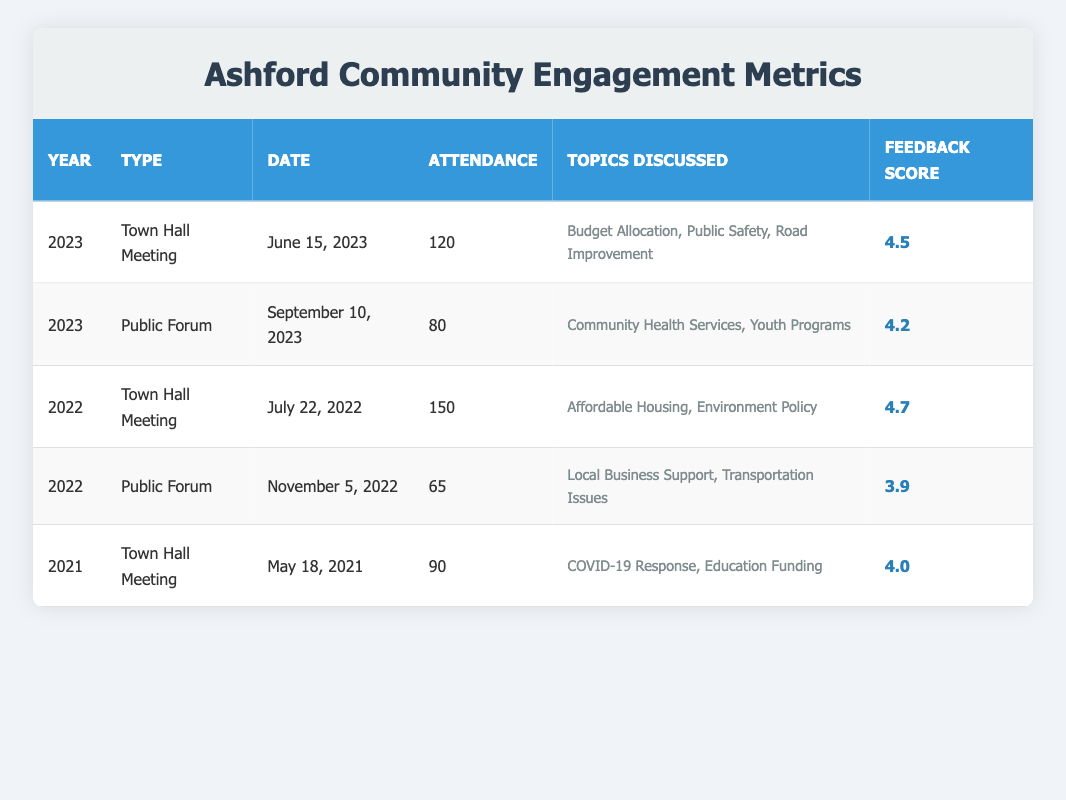What was the attendance at the Town Hall Meeting on June 15, 2023? The table lists the attendance for the Town Hall Meeting on June 15, 2023, as 120.
Answer: 120 What topics were discussed at the Public Forum on September 10, 2023? The table specifies the topics discussed at the Public Forum on September 10, 2023, which were Community Health Services and Youth Programs.
Answer: Community Health Services, Youth Programs Is the feedback score for the Town Hall Meeting in 2022 greater than that of the Public Forum in 2022? The feedback score for the Town Hall Meeting in 2022 is 4.7, while the feedback score for the Public Forum in 2022 is 3.9. Since 4.7 is greater than 3.9, the statement is true.
Answer: Yes What was the average attendance for Town Hall Meetings held in 2022 and 2023? The attendance for Town Hall Meetings in 2022 was 150 and in 2023 was 120. Adding them gives 150 + 120 = 270, and dividing by the number of meetings (2) gives an average of 270 / 2 = 135.
Answer: 135 How many total people attended all the events listed in the table? Adding the attendance numbers: 120 (2023 Town Hall) + 80 (2023 Public Forum) + 150 (2022 Town Hall) + 65 (2022 Public Forum) + 90 (2021 Town Hall) gives 120 + 80 + 150 + 65 + 90 = 505.
Answer: 505 Was the feedback score for any event lower than 4.0? The feedback scores are 4.5, 4.2, 4.7, 3.9, and 4.0. The score of 3.9 for the Public Forum in 2022 is indeed lower than 4.0, indicating that there was at least one score below that threshold.
Answer: Yes What was the most attended event in the last three years? The highest attendance among the listed events occurred at the Town Hall Meeting on July 22, 2022, with 150 attendees, making it the most attended event within the timeframe.
Answer: 150 Which event had the lowest feedback score, and what was the score? The Public Forum on November 5, 2022, had the lowest feedback score of 3.9.
Answer: Public Forum on November 5, 2022; 3.9 